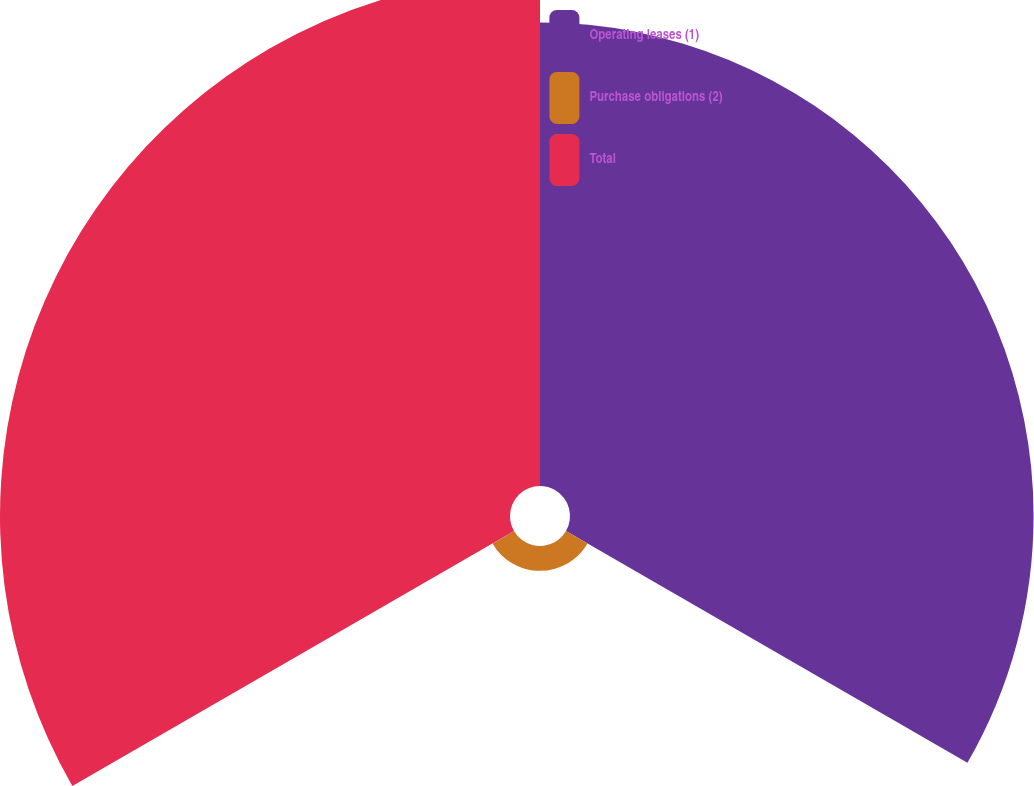Convert chart. <chart><loc_0><loc_0><loc_500><loc_500><pie_chart><fcel>Operating leases (1)<fcel>Purchase obligations (2)<fcel>Total<nl><fcel>46.43%<fcel>2.49%<fcel>51.08%<nl></chart> 